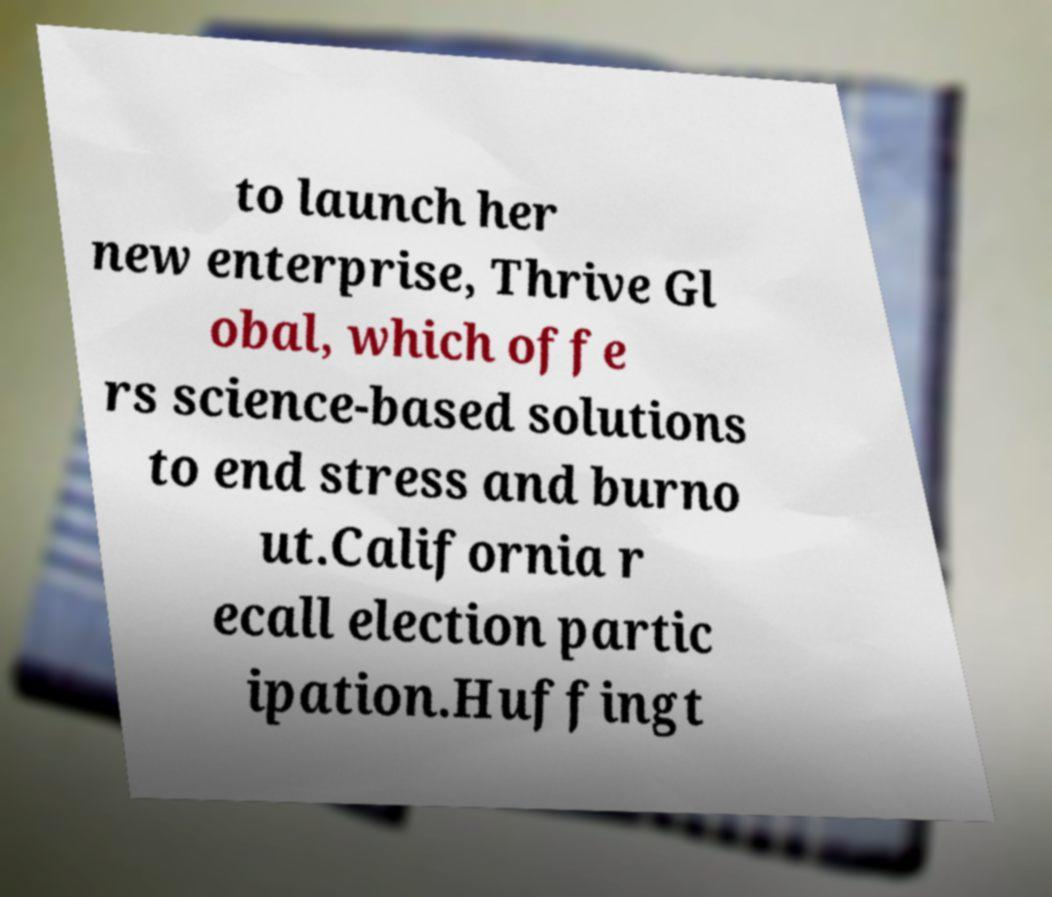What messages or text are displayed in this image? I need them in a readable, typed format. to launch her new enterprise, Thrive Gl obal, which offe rs science-based solutions to end stress and burno ut.California r ecall election partic ipation.Huffingt 